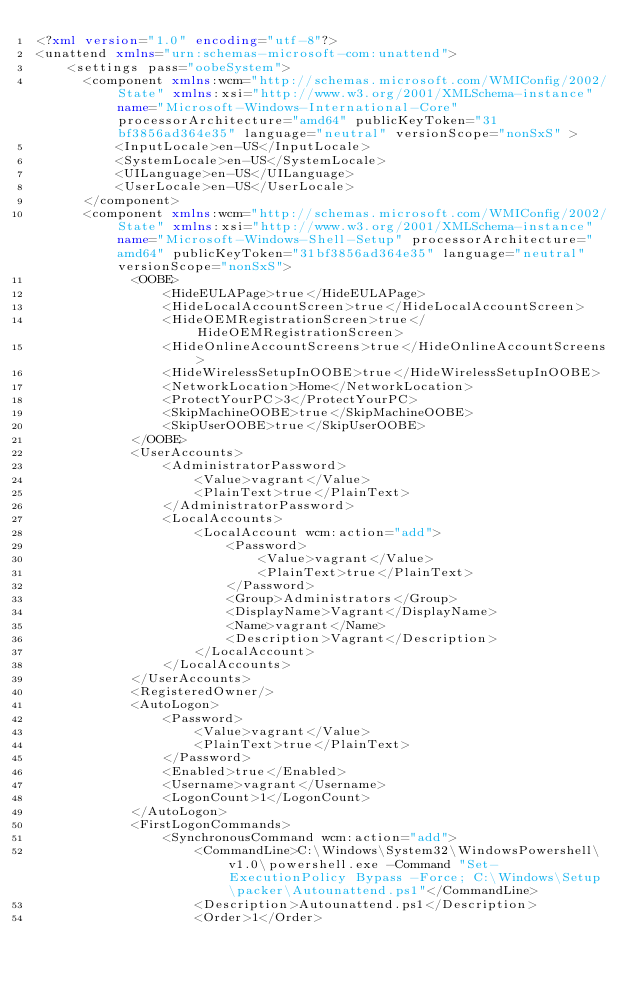Convert code to text. <code><loc_0><loc_0><loc_500><loc_500><_XML_><?xml version="1.0" encoding="utf-8"?>
<unattend xmlns="urn:schemas-microsoft-com:unattend">
    <settings pass="oobeSystem">
      <component xmlns:wcm="http://schemas.microsoft.com/WMIConfig/2002/State" xmlns:xsi="http://www.w3.org/2001/XMLSchema-instance" name="Microsoft-Windows-International-Core" processorArchitecture="amd64" publicKeyToken="31bf3856ad364e35" language="neutral" versionScope="nonSxS" >
          <InputLocale>en-US</InputLocale>
          <SystemLocale>en-US</SystemLocale>
          <UILanguage>en-US</UILanguage>
          <UserLocale>en-US</UserLocale>
      </component>
      <component xmlns:wcm="http://schemas.microsoft.com/WMIConfig/2002/State" xmlns:xsi="http://www.w3.org/2001/XMLSchema-instance" name="Microsoft-Windows-Shell-Setup" processorArchitecture="amd64" publicKeyToken="31bf3856ad364e35" language="neutral" versionScope="nonSxS">
            <OOBE>
                <HideEULAPage>true</HideEULAPage>
                <HideLocalAccountScreen>true</HideLocalAccountScreen>
                <HideOEMRegistrationScreen>true</HideOEMRegistrationScreen>
                <HideOnlineAccountScreens>true</HideOnlineAccountScreens>
                <HideWirelessSetupInOOBE>true</HideWirelessSetupInOOBE>
                <NetworkLocation>Home</NetworkLocation>
                <ProtectYourPC>3</ProtectYourPC>
                <SkipMachineOOBE>true</SkipMachineOOBE>
                <SkipUserOOBE>true</SkipUserOOBE>
            </OOBE>
            <UserAccounts>
                <AdministratorPassword>
                    <Value>vagrant</Value>
                    <PlainText>true</PlainText>
                </AdministratorPassword>
                <LocalAccounts>
                    <LocalAccount wcm:action="add">
                        <Password>
                            <Value>vagrant</Value>
                            <PlainText>true</PlainText>
                        </Password>
                        <Group>Administrators</Group>
                        <DisplayName>Vagrant</DisplayName>
                        <Name>vagrant</Name>
                        <Description>Vagrant</Description>
                    </LocalAccount>
                </LocalAccounts>
            </UserAccounts>
            <RegisteredOwner/>
            <AutoLogon>
                <Password>
                    <Value>vagrant</Value>
                    <PlainText>true</PlainText>
                </Password>
                <Enabled>true</Enabled>
                <Username>vagrant</Username>
                <LogonCount>1</LogonCount>
            </AutoLogon>
            <FirstLogonCommands>
                <SynchronousCommand wcm:action="add">
                    <CommandLine>C:\Windows\System32\WindowsPowershell\v1.0\powershell.exe -Command "Set-ExecutionPolicy Bypass -Force; C:\Windows\Setup\packer\Autounattend.ps1"</CommandLine>
                    <Description>Autounattend.ps1</Description>
                    <Order>1</Order></code> 